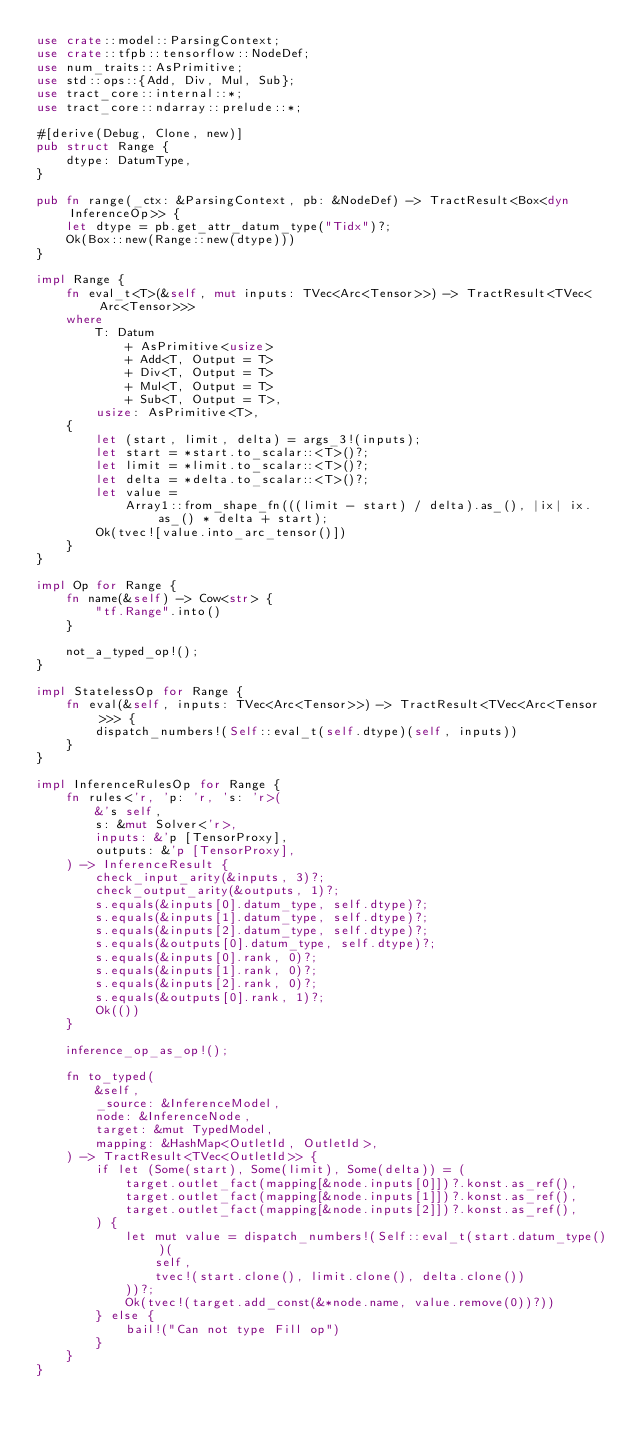Convert code to text. <code><loc_0><loc_0><loc_500><loc_500><_Rust_>use crate::model::ParsingContext;
use crate::tfpb::tensorflow::NodeDef;
use num_traits::AsPrimitive;
use std::ops::{Add, Div, Mul, Sub};
use tract_core::internal::*;
use tract_core::ndarray::prelude::*;

#[derive(Debug, Clone, new)]
pub struct Range {
    dtype: DatumType,
}

pub fn range(_ctx: &ParsingContext, pb: &NodeDef) -> TractResult<Box<dyn InferenceOp>> {
    let dtype = pb.get_attr_datum_type("Tidx")?;
    Ok(Box::new(Range::new(dtype)))
}

impl Range {
    fn eval_t<T>(&self, mut inputs: TVec<Arc<Tensor>>) -> TractResult<TVec<Arc<Tensor>>>
    where
        T: Datum
            + AsPrimitive<usize>
            + Add<T, Output = T>
            + Div<T, Output = T>
            + Mul<T, Output = T>
            + Sub<T, Output = T>,
        usize: AsPrimitive<T>,
    {
        let (start, limit, delta) = args_3!(inputs);
        let start = *start.to_scalar::<T>()?;
        let limit = *limit.to_scalar::<T>()?;
        let delta = *delta.to_scalar::<T>()?;
        let value =
            Array1::from_shape_fn(((limit - start) / delta).as_(), |ix| ix.as_() * delta + start);
        Ok(tvec![value.into_arc_tensor()])
    }
}

impl Op for Range {
    fn name(&self) -> Cow<str> {
        "tf.Range".into()
    }

    not_a_typed_op!();
}

impl StatelessOp for Range {
    fn eval(&self, inputs: TVec<Arc<Tensor>>) -> TractResult<TVec<Arc<Tensor>>> {
        dispatch_numbers!(Self::eval_t(self.dtype)(self, inputs))
    }
}

impl InferenceRulesOp for Range {
    fn rules<'r, 'p: 'r, 's: 'r>(
        &'s self,
        s: &mut Solver<'r>,
        inputs: &'p [TensorProxy],
        outputs: &'p [TensorProxy],
    ) -> InferenceResult {
        check_input_arity(&inputs, 3)?;
        check_output_arity(&outputs, 1)?;
        s.equals(&inputs[0].datum_type, self.dtype)?;
        s.equals(&inputs[1].datum_type, self.dtype)?;
        s.equals(&inputs[2].datum_type, self.dtype)?;
        s.equals(&outputs[0].datum_type, self.dtype)?;
        s.equals(&inputs[0].rank, 0)?;
        s.equals(&inputs[1].rank, 0)?;
        s.equals(&inputs[2].rank, 0)?;
        s.equals(&outputs[0].rank, 1)?;
        Ok(())
    }

    inference_op_as_op!();

    fn to_typed(
        &self,
        _source: &InferenceModel,
        node: &InferenceNode,
        target: &mut TypedModel,
        mapping: &HashMap<OutletId, OutletId>,
    ) -> TractResult<TVec<OutletId>> {
        if let (Some(start), Some(limit), Some(delta)) = (
            target.outlet_fact(mapping[&node.inputs[0]])?.konst.as_ref(),
            target.outlet_fact(mapping[&node.inputs[1]])?.konst.as_ref(),
            target.outlet_fact(mapping[&node.inputs[2]])?.konst.as_ref(),
        ) {
            let mut value = dispatch_numbers!(Self::eval_t(start.datum_type())(
                self,
                tvec!(start.clone(), limit.clone(), delta.clone())
            ))?;
            Ok(tvec!(target.add_const(&*node.name, value.remove(0))?))
        } else {
            bail!("Can not type Fill op")
        }
    }
}
</code> 